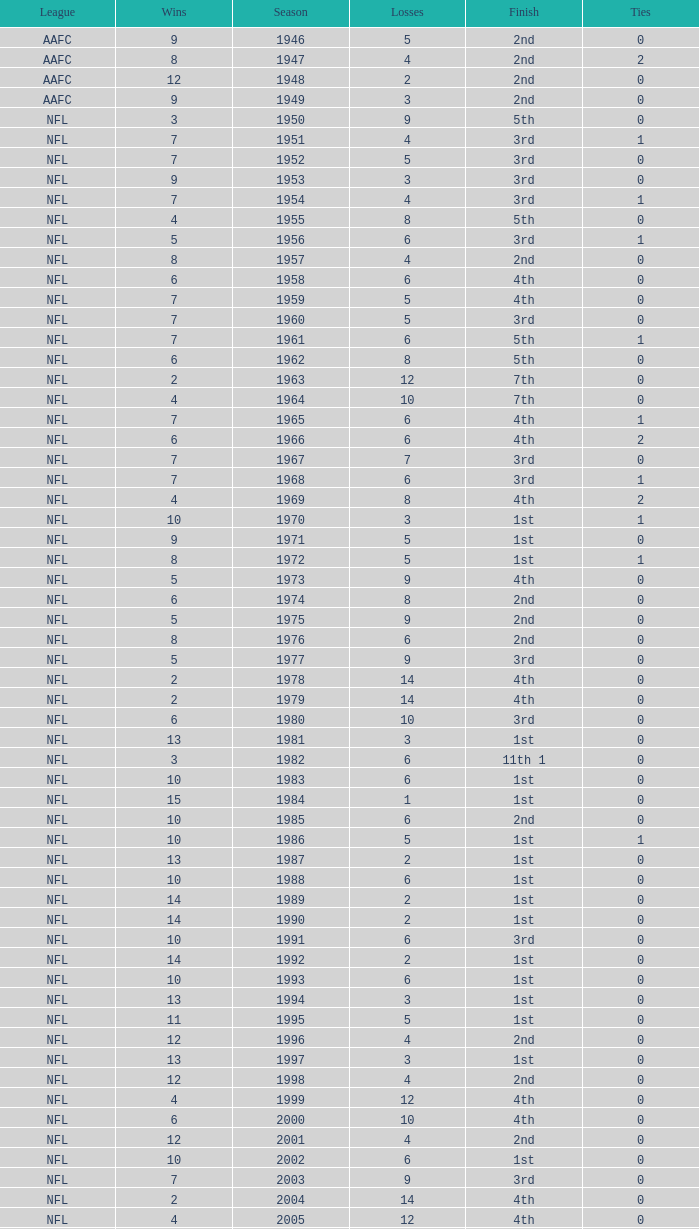What league had a finish of 2nd and 3 losses? AAFC. 